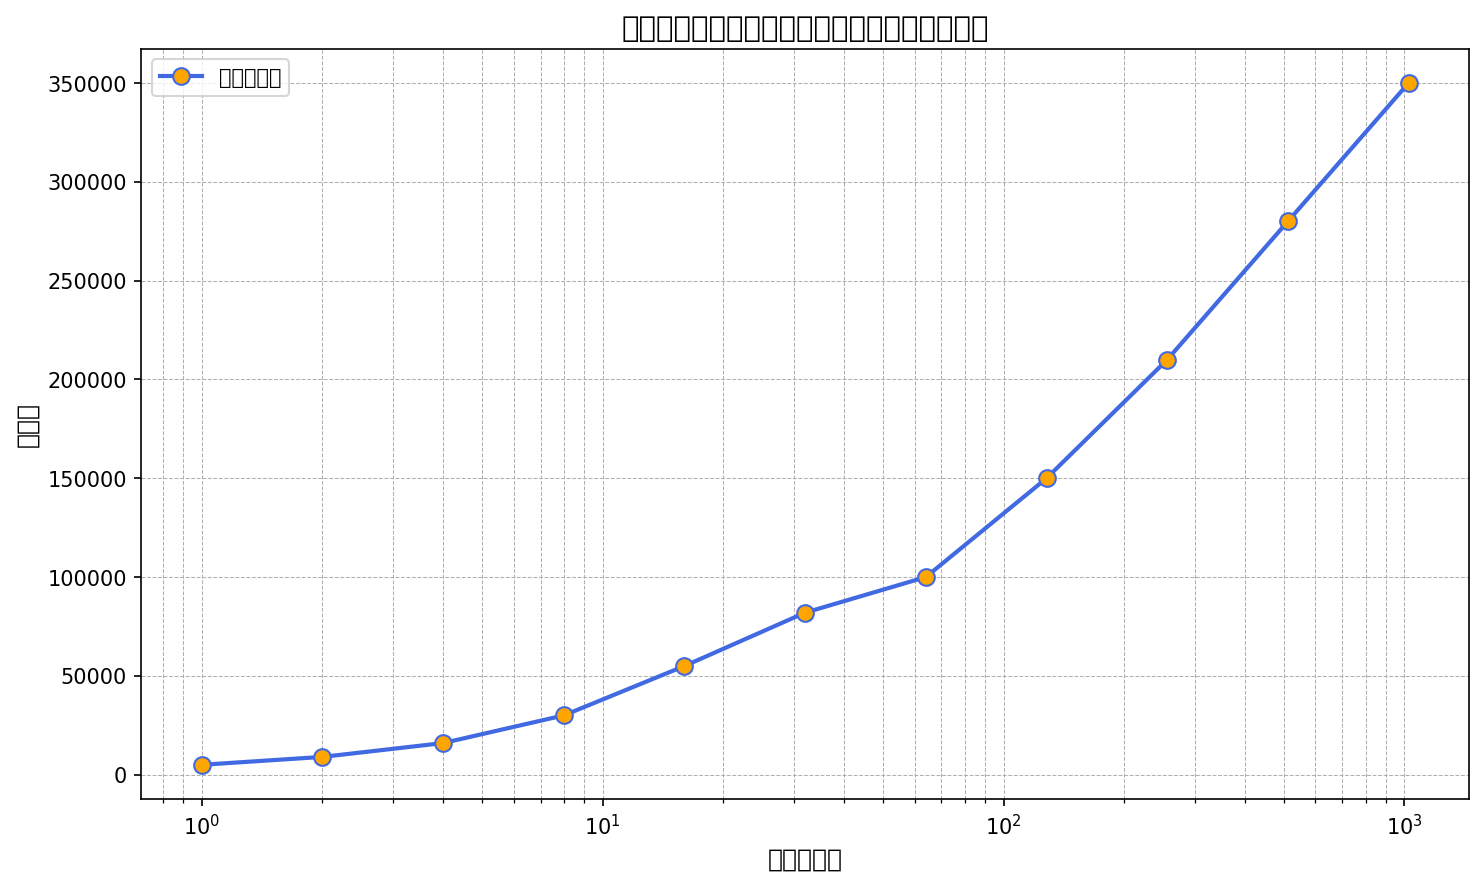What is the initial number of fans at 1 month? Locate the data point where 时间（月）= 1 and read the corresponding 粉丝数 value.
Answer: 5000 How does the number of fans change between 8 months and 16 months? Find the 粉丝数 values at 8 months and 16 months, then calculate the difference: 55000 (16 months) - 30000 (8 months).
Answer: 25000 Between which two periods does the number of fans increase the most? Examine the differences in 粉丝数 between consecutive data points and identify the period with the largest increase. The largest difference is between 1 month (5000) and 2 months (9000).
Answer: Between 1 and 2 months What is the average number of fans from the observed data? Sum all 粉丝数 values and divide by the count of data points: (5000 + 9000 + 16000 + 30000 + 55000 + 82000 + 100000 + 150000 + 210000 + 280000 + 350000) / 11.
Answer: 100636 At what time period does the number of fans reach 100000? Locate the data point where 粉丝数 = 100000 and read the corresponding 时间（月） value.
Answer: 64 months How many times does the number of fans increase from 1 month to 32 months? Calculate the ratio of 粉丝数 at 32 months to 1 month: 82000 / 5000.
Answer: 16.4 Which period shows a slower growth rate, between 32 to 64 months or 256 to 512 months? Calculate the growth rates for both periods: (100000 - 82000) / (64 - 32) and (280000 - 210000) / (512 - 256), and compare their values.
Answer: 32 to 64 months What is the visual pattern of the fan growth in the plot? Describe the trend and characteristics visible in the plot, noting that the x-axis is logarithmic and curves upward steadily.
Answer: Exponential growth Is the increase in fan base more rapid in the early months or later months? Observe the slope of the line on the logscale x-axis plot. A steeper slope indicates a faster increase. The slope is steeper in the earlier months.
Answer: Early months Compare the fan numbers at 256 months and 512 months. Which has more fans? Locate the 粉丝数 at 256 months and 512 months. Since 280000 (512 months) > 210000 (256 months), 512 months has more fans.
Answer: 512 months 